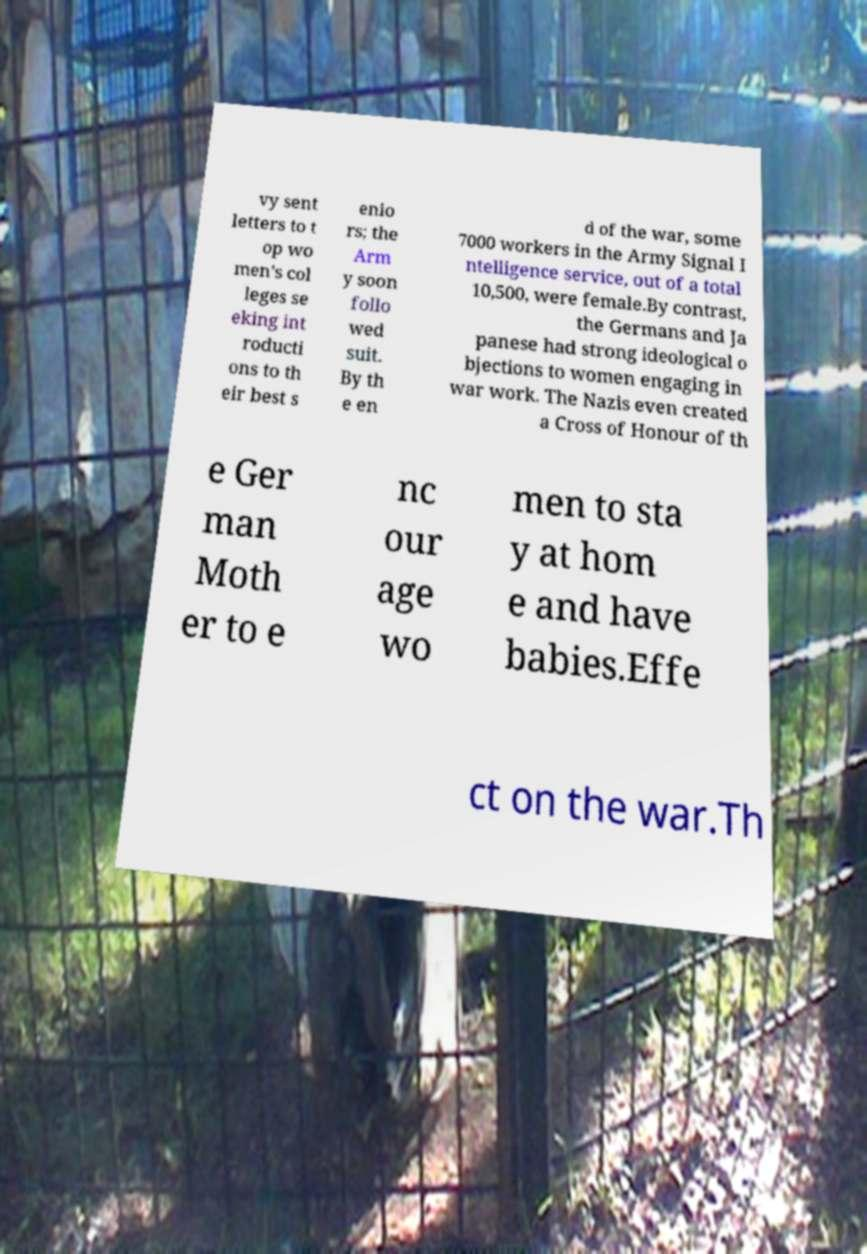Can you read and provide the text displayed in the image?This photo seems to have some interesting text. Can you extract and type it out for me? vy sent letters to t op wo men's col leges se eking int roducti ons to th eir best s enio rs; the Arm y soon follo wed suit. By th e en d of the war, some 7000 workers in the Army Signal I ntelligence service, out of a total 10,500, were female.By contrast, the Germans and Ja panese had strong ideological o bjections to women engaging in war work. The Nazis even created a Cross of Honour of th e Ger man Moth er to e nc our age wo men to sta y at hom e and have babies.Effe ct on the war.Th 